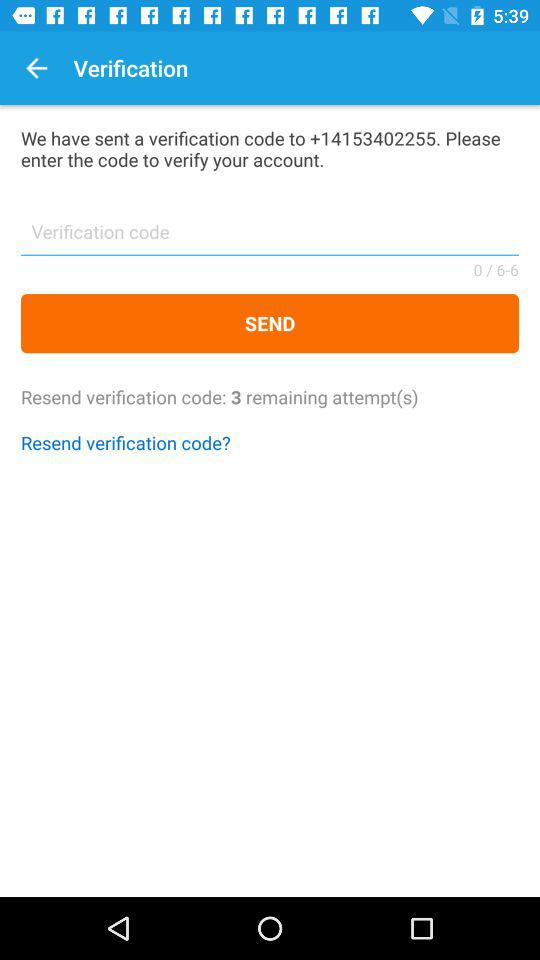How many attempts do I have left to enter the verification code?
Answer the question using a single word or phrase. 3 